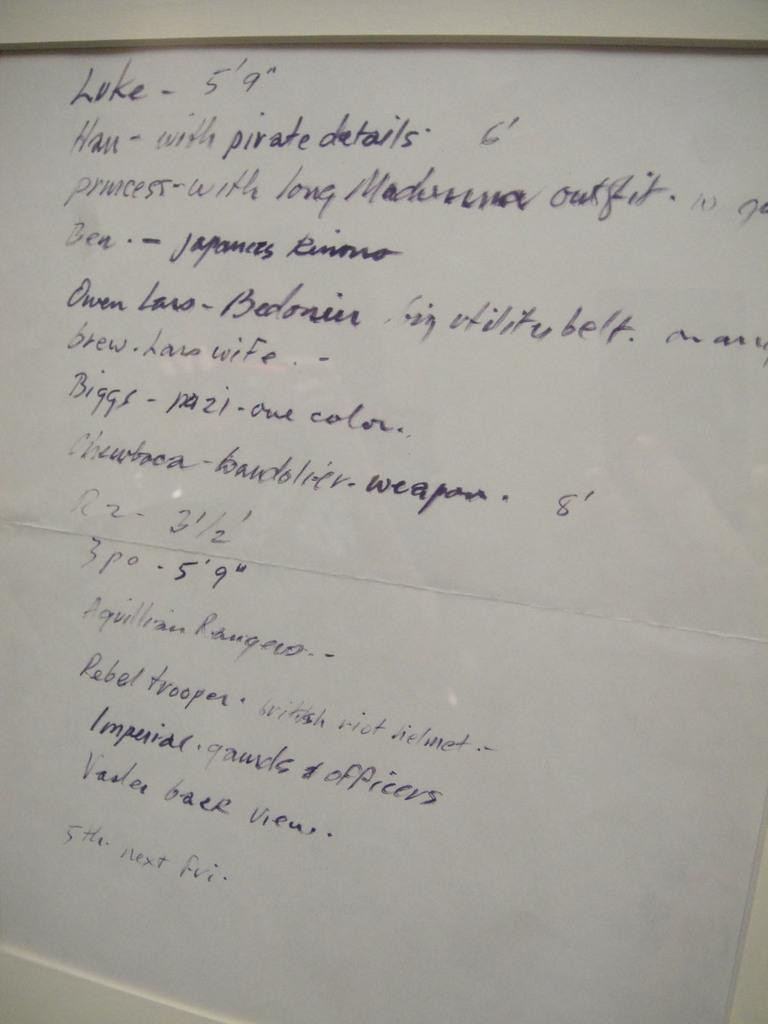<image>
Share a concise interpretation of the image provided. A handwritten page of writing which starts with the word Luke. 